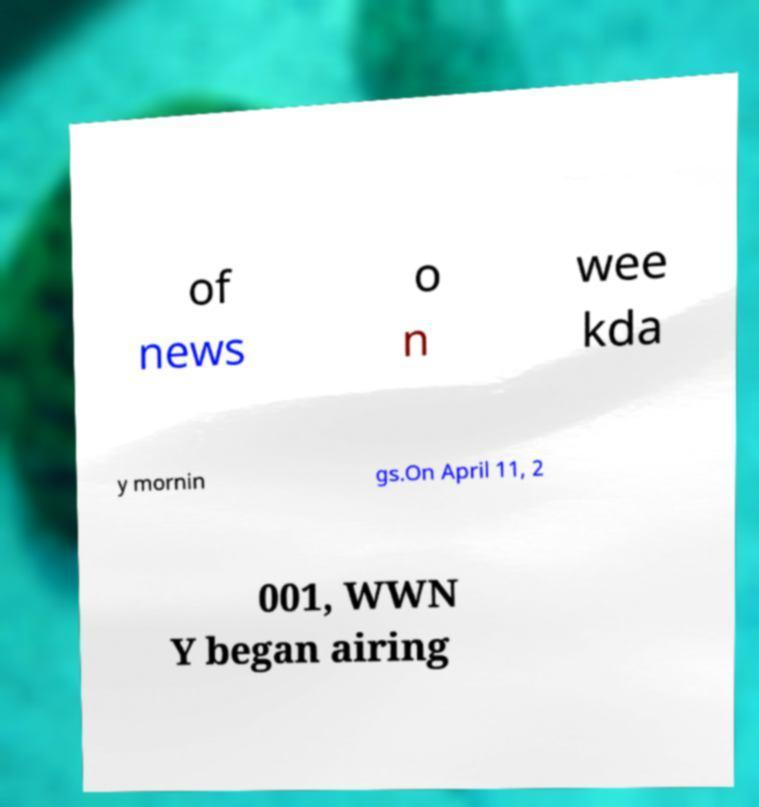What messages or text are displayed in this image? I need them in a readable, typed format. of news o n wee kda y mornin gs.On April 11, 2 001, WWN Y began airing 